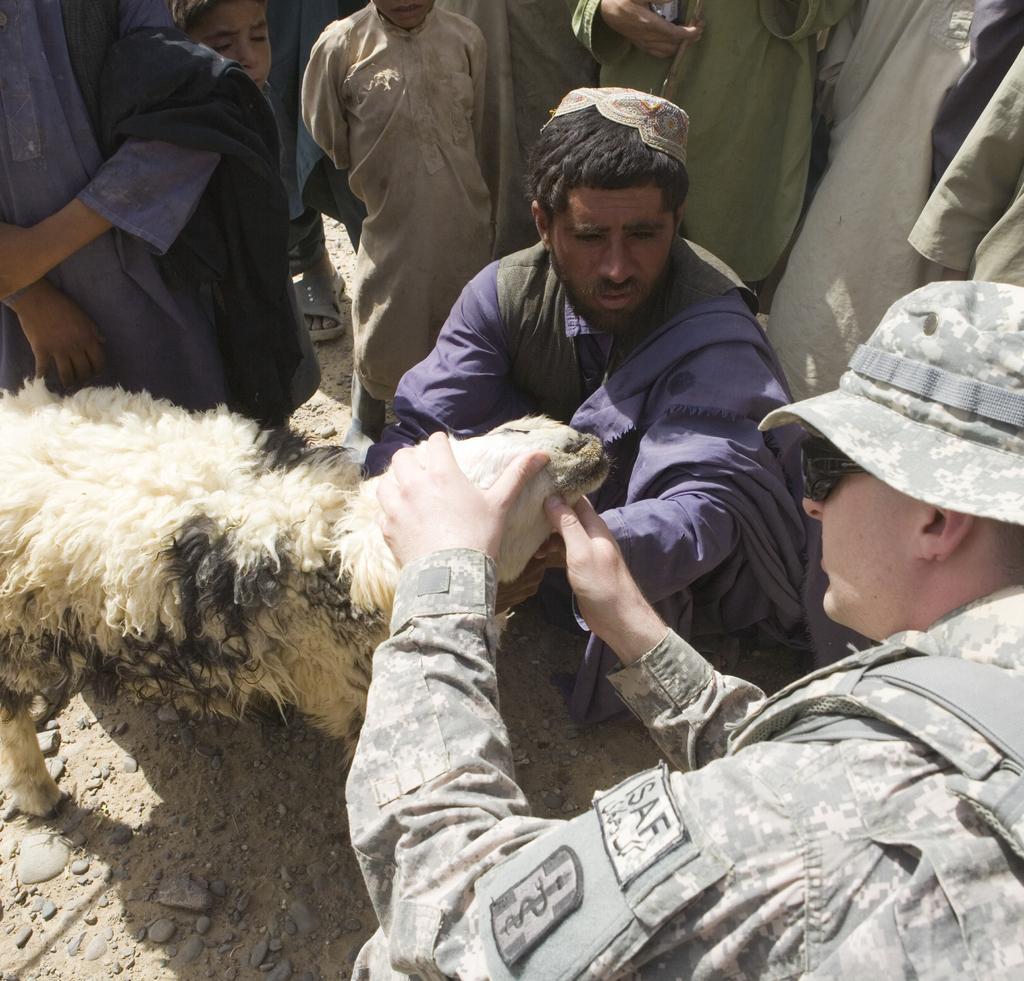In one or two sentences, can you explain what this image depicts? In the image there is a sheep. Around it many people are there. A man wearing a cap and uniform is holding the head of the sheep. A man wearing blue dress is on crouch position. 